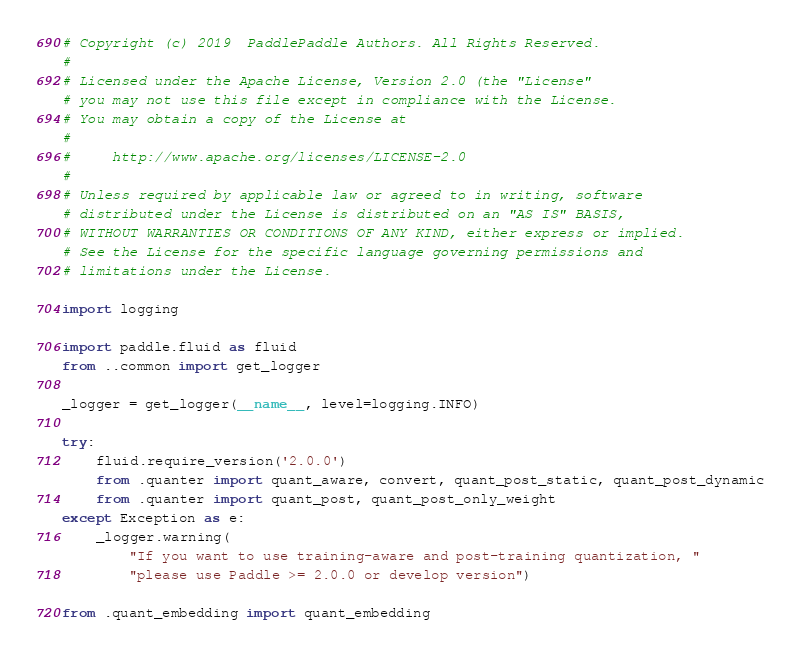Convert code to text. <code><loc_0><loc_0><loc_500><loc_500><_Python_># Copyright (c) 2019  PaddlePaddle Authors. All Rights Reserved.
#
# Licensed under the Apache License, Version 2.0 (the "License"
# you may not use this file except in compliance with the License.
# You may obtain a copy of the License at
#
#     http://www.apache.org/licenses/LICENSE-2.0
#
# Unless required by applicable law or agreed to in writing, software
# distributed under the License is distributed on an "AS IS" BASIS,
# WITHOUT WARRANTIES OR CONDITIONS OF ANY KIND, either express or implied.
# See the License for the specific language governing permissions and
# limitations under the License.

import logging

import paddle.fluid as fluid
from ..common import get_logger

_logger = get_logger(__name__, level=logging.INFO)

try:
    fluid.require_version('2.0.0')
    from .quanter import quant_aware, convert, quant_post_static, quant_post_dynamic
    from .quanter import quant_post, quant_post_only_weight
except Exception as e:
    _logger.warning(
        "If you want to use training-aware and post-training quantization, "
        "please use Paddle >= 2.0.0 or develop version")

from .quant_embedding import quant_embedding
</code> 